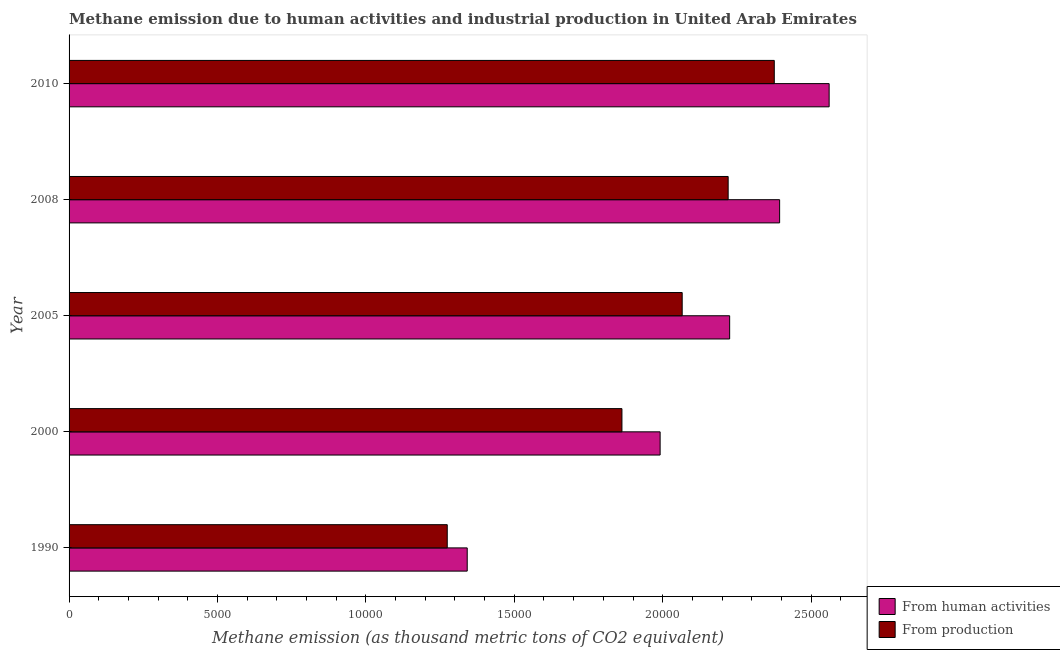How many groups of bars are there?
Make the answer very short. 5. What is the label of the 1st group of bars from the top?
Offer a very short reply. 2010. What is the amount of emissions generated from industries in 2008?
Make the answer very short. 2.22e+04. Across all years, what is the maximum amount of emissions generated from industries?
Offer a very short reply. 2.38e+04. Across all years, what is the minimum amount of emissions generated from industries?
Your answer should be compact. 1.27e+04. In which year was the amount of emissions generated from industries maximum?
Provide a short and direct response. 2010. What is the total amount of emissions from human activities in the graph?
Provide a short and direct response. 1.05e+05. What is the difference between the amount of emissions from human activities in 1990 and that in 2010?
Your answer should be compact. -1.22e+04. What is the difference between the amount of emissions from human activities in 2000 and the amount of emissions generated from industries in 2010?
Your answer should be very brief. -3846.1. What is the average amount of emissions generated from industries per year?
Ensure brevity in your answer.  1.96e+04. In the year 2010, what is the difference between the amount of emissions from human activities and amount of emissions generated from industries?
Make the answer very short. 1848.3. What is the ratio of the amount of emissions from human activities in 2008 to that in 2010?
Your answer should be compact. 0.94. Is the amount of emissions generated from industries in 2005 less than that in 2010?
Provide a succinct answer. Yes. Is the difference between the amount of emissions from human activities in 1990 and 2005 greater than the difference between the amount of emissions generated from industries in 1990 and 2005?
Make the answer very short. No. What is the difference between the highest and the second highest amount of emissions from human activities?
Your answer should be very brief. 1668.5. What is the difference between the highest and the lowest amount of emissions from human activities?
Offer a terse response. 1.22e+04. Is the sum of the amount of emissions from human activities in 1990 and 2010 greater than the maximum amount of emissions generated from industries across all years?
Offer a terse response. Yes. What does the 1st bar from the top in 2005 represents?
Your answer should be very brief. From production. What does the 2nd bar from the bottom in 1990 represents?
Provide a succinct answer. From production. Are all the bars in the graph horizontal?
Give a very brief answer. Yes. Does the graph contain any zero values?
Your response must be concise. No. Does the graph contain grids?
Keep it short and to the point. No. How are the legend labels stacked?
Offer a very short reply. Vertical. What is the title of the graph?
Keep it short and to the point. Methane emission due to human activities and industrial production in United Arab Emirates. Does "Short-term debt" appear as one of the legend labels in the graph?
Offer a terse response. No. What is the label or title of the X-axis?
Offer a terse response. Methane emission (as thousand metric tons of CO2 equivalent). What is the Methane emission (as thousand metric tons of CO2 equivalent) in From human activities in 1990?
Give a very brief answer. 1.34e+04. What is the Methane emission (as thousand metric tons of CO2 equivalent) of From production in 1990?
Provide a succinct answer. 1.27e+04. What is the Methane emission (as thousand metric tons of CO2 equivalent) in From human activities in 2000?
Keep it short and to the point. 1.99e+04. What is the Methane emission (as thousand metric tons of CO2 equivalent) in From production in 2000?
Ensure brevity in your answer.  1.86e+04. What is the Methane emission (as thousand metric tons of CO2 equivalent) in From human activities in 2005?
Your answer should be compact. 2.23e+04. What is the Methane emission (as thousand metric tons of CO2 equivalent) in From production in 2005?
Your response must be concise. 2.07e+04. What is the Methane emission (as thousand metric tons of CO2 equivalent) of From human activities in 2008?
Provide a succinct answer. 2.39e+04. What is the Methane emission (as thousand metric tons of CO2 equivalent) of From production in 2008?
Keep it short and to the point. 2.22e+04. What is the Methane emission (as thousand metric tons of CO2 equivalent) of From human activities in 2010?
Offer a very short reply. 2.56e+04. What is the Methane emission (as thousand metric tons of CO2 equivalent) in From production in 2010?
Your answer should be very brief. 2.38e+04. Across all years, what is the maximum Methane emission (as thousand metric tons of CO2 equivalent) in From human activities?
Your response must be concise. 2.56e+04. Across all years, what is the maximum Methane emission (as thousand metric tons of CO2 equivalent) in From production?
Offer a very short reply. 2.38e+04. Across all years, what is the minimum Methane emission (as thousand metric tons of CO2 equivalent) of From human activities?
Provide a succinct answer. 1.34e+04. Across all years, what is the minimum Methane emission (as thousand metric tons of CO2 equivalent) of From production?
Provide a short and direct response. 1.27e+04. What is the total Methane emission (as thousand metric tons of CO2 equivalent) in From human activities in the graph?
Give a very brief answer. 1.05e+05. What is the total Methane emission (as thousand metric tons of CO2 equivalent) in From production in the graph?
Keep it short and to the point. 9.80e+04. What is the difference between the Methane emission (as thousand metric tons of CO2 equivalent) in From human activities in 1990 and that in 2000?
Your answer should be very brief. -6499. What is the difference between the Methane emission (as thousand metric tons of CO2 equivalent) of From production in 1990 and that in 2000?
Your answer should be very brief. -5885.7. What is the difference between the Methane emission (as thousand metric tons of CO2 equivalent) of From human activities in 1990 and that in 2005?
Keep it short and to the point. -8841.4. What is the difference between the Methane emission (as thousand metric tons of CO2 equivalent) in From production in 1990 and that in 2005?
Provide a short and direct response. -7915.3. What is the difference between the Methane emission (as thousand metric tons of CO2 equivalent) of From human activities in 1990 and that in 2008?
Keep it short and to the point. -1.05e+04. What is the difference between the Methane emission (as thousand metric tons of CO2 equivalent) of From production in 1990 and that in 2008?
Provide a short and direct response. -9464.3. What is the difference between the Methane emission (as thousand metric tons of CO2 equivalent) in From human activities in 1990 and that in 2010?
Provide a succinct answer. -1.22e+04. What is the difference between the Methane emission (as thousand metric tons of CO2 equivalent) of From production in 1990 and that in 2010?
Keep it short and to the point. -1.10e+04. What is the difference between the Methane emission (as thousand metric tons of CO2 equivalent) of From human activities in 2000 and that in 2005?
Ensure brevity in your answer.  -2342.4. What is the difference between the Methane emission (as thousand metric tons of CO2 equivalent) in From production in 2000 and that in 2005?
Offer a very short reply. -2029.6. What is the difference between the Methane emission (as thousand metric tons of CO2 equivalent) in From human activities in 2000 and that in 2008?
Give a very brief answer. -4025.9. What is the difference between the Methane emission (as thousand metric tons of CO2 equivalent) in From production in 2000 and that in 2008?
Give a very brief answer. -3578.6. What is the difference between the Methane emission (as thousand metric tons of CO2 equivalent) in From human activities in 2000 and that in 2010?
Provide a succinct answer. -5694.4. What is the difference between the Methane emission (as thousand metric tons of CO2 equivalent) in From production in 2000 and that in 2010?
Offer a very short reply. -5132.6. What is the difference between the Methane emission (as thousand metric tons of CO2 equivalent) in From human activities in 2005 and that in 2008?
Your answer should be very brief. -1683.5. What is the difference between the Methane emission (as thousand metric tons of CO2 equivalent) in From production in 2005 and that in 2008?
Ensure brevity in your answer.  -1549. What is the difference between the Methane emission (as thousand metric tons of CO2 equivalent) in From human activities in 2005 and that in 2010?
Your answer should be compact. -3352. What is the difference between the Methane emission (as thousand metric tons of CO2 equivalent) in From production in 2005 and that in 2010?
Keep it short and to the point. -3103. What is the difference between the Methane emission (as thousand metric tons of CO2 equivalent) of From human activities in 2008 and that in 2010?
Make the answer very short. -1668.5. What is the difference between the Methane emission (as thousand metric tons of CO2 equivalent) in From production in 2008 and that in 2010?
Your answer should be very brief. -1554. What is the difference between the Methane emission (as thousand metric tons of CO2 equivalent) of From human activities in 1990 and the Methane emission (as thousand metric tons of CO2 equivalent) of From production in 2000?
Ensure brevity in your answer.  -5212.5. What is the difference between the Methane emission (as thousand metric tons of CO2 equivalent) of From human activities in 1990 and the Methane emission (as thousand metric tons of CO2 equivalent) of From production in 2005?
Provide a succinct answer. -7242.1. What is the difference between the Methane emission (as thousand metric tons of CO2 equivalent) of From human activities in 1990 and the Methane emission (as thousand metric tons of CO2 equivalent) of From production in 2008?
Your response must be concise. -8791.1. What is the difference between the Methane emission (as thousand metric tons of CO2 equivalent) in From human activities in 1990 and the Methane emission (as thousand metric tons of CO2 equivalent) in From production in 2010?
Provide a succinct answer. -1.03e+04. What is the difference between the Methane emission (as thousand metric tons of CO2 equivalent) in From human activities in 2000 and the Methane emission (as thousand metric tons of CO2 equivalent) in From production in 2005?
Ensure brevity in your answer.  -743.1. What is the difference between the Methane emission (as thousand metric tons of CO2 equivalent) in From human activities in 2000 and the Methane emission (as thousand metric tons of CO2 equivalent) in From production in 2008?
Provide a succinct answer. -2292.1. What is the difference between the Methane emission (as thousand metric tons of CO2 equivalent) of From human activities in 2000 and the Methane emission (as thousand metric tons of CO2 equivalent) of From production in 2010?
Provide a succinct answer. -3846.1. What is the difference between the Methane emission (as thousand metric tons of CO2 equivalent) in From human activities in 2005 and the Methane emission (as thousand metric tons of CO2 equivalent) in From production in 2008?
Your answer should be compact. 50.3. What is the difference between the Methane emission (as thousand metric tons of CO2 equivalent) in From human activities in 2005 and the Methane emission (as thousand metric tons of CO2 equivalent) in From production in 2010?
Keep it short and to the point. -1503.7. What is the difference between the Methane emission (as thousand metric tons of CO2 equivalent) of From human activities in 2008 and the Methane emission (as thousand metric tons of CO2 equivalent) of From production in 2010?
Provide a succinct answer. 179.8. What is the average Methane emission (as thousand metric tons of CO2 equivalent) in From human activities per year?
Provide a succinct answer. 2.10e+04. What is the average Methane emission (as thousand metric tons of CO2 equivalent) in From production per year?
Give a very brief answer. 1.96e+04. In the year 1990, what is the difference between the Methane emission (as thousand metric tons of CO2 equivalent) of From human activities and Methane emission (as thousand metric tons of CO2 equivalent) of From production?
Provide a succinct answer. 673.2. In the year 2000, what is the difference between the Methane emission (as thousand metric tons of CO2 equivalent) of From human activities and Methane emission (as thousand metric tons of CO2 equivalent) of From production?
Your response must be concise. 1286.5. In the year 2005, what is the difference between the Methane emission (as thousand metric tons of CO2 equivalent) of From human activities and Methane emission (as thousand metric tons of CO2 equivalent) of From production?
Give a very brief answer. 1599.3. In the year 2008, what is the difference between the Methane emission (as thousand metric tons of CO2 equivalent) of From human activities and Methane emission (as thousand metric tons of CO2 equivalent) of From production?
Your answer should be compact. 1733.8. In the year 2010, what is the difference between the Methane emission (as thousand metric tons of CO2 equivalent) of From human activities and Methane emission (as thousand metric tons of CO2 equivalent) of From production?
Offer a terse response. 1848.3. What is the ratio of the Methane emission (as thousand metric tons of CO2 equivalent) of From human activities in 1990 to that in 2000?
Your response must be concise. 0.67. What is the ratio of the Methane emission (as thousand metric tons of CO2 equivalent) in From production in 1990 to that in 2000?
Offer a terse response. 0.68. What is the ratio of the Methane emission (as thousand metric tons of CO2 equivalent) in From human activities in 1990 to that in 2005?
Provide a short and direct response. 0.6. What is the ratio of the Methane emission (as thousand metric tons of CO2 equivalent) in From production in 1990 to that in 2005?
Provide a succinct answer. 0.62. What is the ratio of the Methane emission (as thousand metric tons of CO2 equivalent) in From human activities in 1990 to that in 2008?
Give a very brief answer. 0.56. What is the ratio of the Methane emission (as thousand metric tons of CO2 equivalent) in From production in 1990 to that in 2008?
Your answer should be compact. 0.57. What is the ratio of the Methane emission (as thousand metric tons of CO2 equivalent) of From human activities in 1990 to that in 2010?
Offer a terse response. 0.52. What is the ratio of the Methane emission (as thousand metric tons of CO2 equivalent) of From production in 1990 to that in 2010?
Make the answer very short. 0.54. What is the ratio of the Methane emission (as thousand metric tons of CO2 equivalent) of From human activities in 2000 to that in 2005?
Ensure brevity in your answer.  0.89. What is the ratio of the Methane emission (as thousand metric tons of CO2 equivalent) in From production in 2000 to that in 2005?
Ensure brevity in your answer.  0.9. What is the ratio of the Methane emission (as thousand metric tons of CO2 equivalent) of From human activities in 2000 to that in 2008?
Offer a very short reply. 0.83. What is the ratio of the Methane emission (as thousand metric tons of CO2 equivalent) of From production in 2000 to that in 2008?
Offer a terse response. 0.84. What is the ratio of the Methane emission (as thousand metric tons of CO2 equivalent) of From human activities in 2000 to that in 2010?
Your answer should be compact. 0.78. What is the ratio of the Methane emission (as thousand metric tons of CO2 equivalent) in From production in 2000 to that in 2010?
Provide a succinct answer. 0.78. What is the ratio of the Methane emission (as thousand metric tons of CO2 equivalent) of From human activities in 2005 to that in 2008?
Ensure brevity in your answer.  0.93. What is the ratio of the Methane emission (as thousand metric tons of CO2 equivalent) in From production in 2005 to that in 2008?
Ensure brevity in your answer.  0.93. What is the ratio of the Methane emission (as thousand metric tons of CO2 equivalent) of From human activities in 2005 to that in 2010?
Provide a short and direct response. 0.87. What is the ratio of the Methane emission (as thousand metric tons of CO2 equivalent) in From production in 2005 to that in 2010?
Keep it short and to the point. 0.87. What is the ratio of the Methane emission (as thousand metric tons of CO2 equivalent) of From human activities in 2008 to that in 2010?
Ensure brevity in your answer.  0.93. What is the ratio of the Methane emission (as thousand metric tons of CO2 equivalent) in From production in 2008 to that in 2010?
Offer a very short reply. 0.93. What is the difference between the highest and the second highest Methane emission (as thousand metric tons of CO2 equivalent) of From human activities?
Provide a succinct answer. 1668.5. What is the difference between the highest and the second highest Methane emission (as thousand metric tons of CO2 equivalent) of From production?
Offer a terse response. 1554. What is the difference between the highest and the lowest Methane emission (as thousand metric tons of CO2 equivalent) of From human activities?
Provide a succinct answer. 1.22e+04. What is the difference between the highest and the lowest Methane emission (as thousand metric tons of CO2 equivalent) in From production?
Your answer should be very brief. 1.10e+04. 